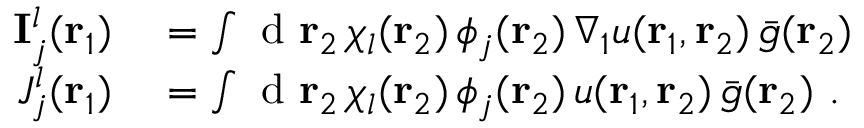<formula> <loc_0><loc_0><loc_500><loc_500>\begin{array} { r l } { I _ { j } ^ { l } ( { r _ { 1 } } ) } & = \int d { r _ { 2 } } \, \chi _ { l } ( { r _ { 2 } } ) \, \phi _ { j } ( { r _ { 2 } } ) \, \nabla _ { 1 } u ( { r _ { 1 } } , { r _ { 2 } } ) \, \bar { g } ( { r _ { 2 } } ) } \\ { J _ { j } ^ { l } ( { r _ { 1 } } ) } & = \int d { r _ { 2 } } \, \chi _ { l } ( { r _ { 2 } } ) \, \phi _ { j } ( { r _ { 2 } } ) \, u ( { r _ { 1 } } , { r _ { 2 } } ) \, \bar { g } ( { r _ { 2 } } ) . } \end{array}</formula> 